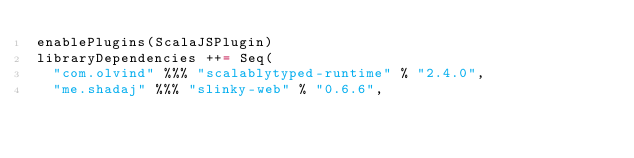<code> <loc_0><loc_0><loc_500><loc_500><_Scala_>enablePlugins(ScalaJSPlugin)
libraryDependencies ++= Seq(
  "com.olvind" %%% "scalablytyped-runtime" % "2.4.0",
  "me.shadaj" %%% "slinky-web" % "0.6.6",</code> 